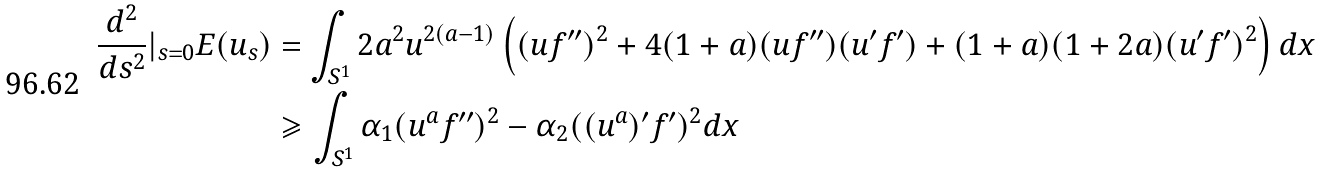<formula> <loc_0><loc_0><loc_500><loc_500>\frac { d ^ { 2 } } { d s ^ { 2 } } | _ { s = 0 } E ( u _ { s } ) & = \int _ { S ^ { 1 } } 2 a ^ { 2 } u ^ { 2 ( a - 1 ) } \left ( ( u f ^ { \prime \prime } ) ^ { 2 } + 4 ( 1 + a ) ( u f ^ { \prime \prime } ) ( u ^ { \prime } f ^ { \prime } ) + ( 1 + a ) ( 1 + 2 a ) ( u ^ { \prime } f ^ { \prime } ) ^ { 2 } \right ) d x \\ & \geqslant \int _ { S ^ { 1 } } \alpha _ { 1 } ( u ^ { a } f ^ { \prime \prime } ) ^ { 2 } - \alpha _ { 2 } ( ( u ^ { a } ) ^ { \prime } f ^ { \prime } ) ^ { 2 } d x</formula> 